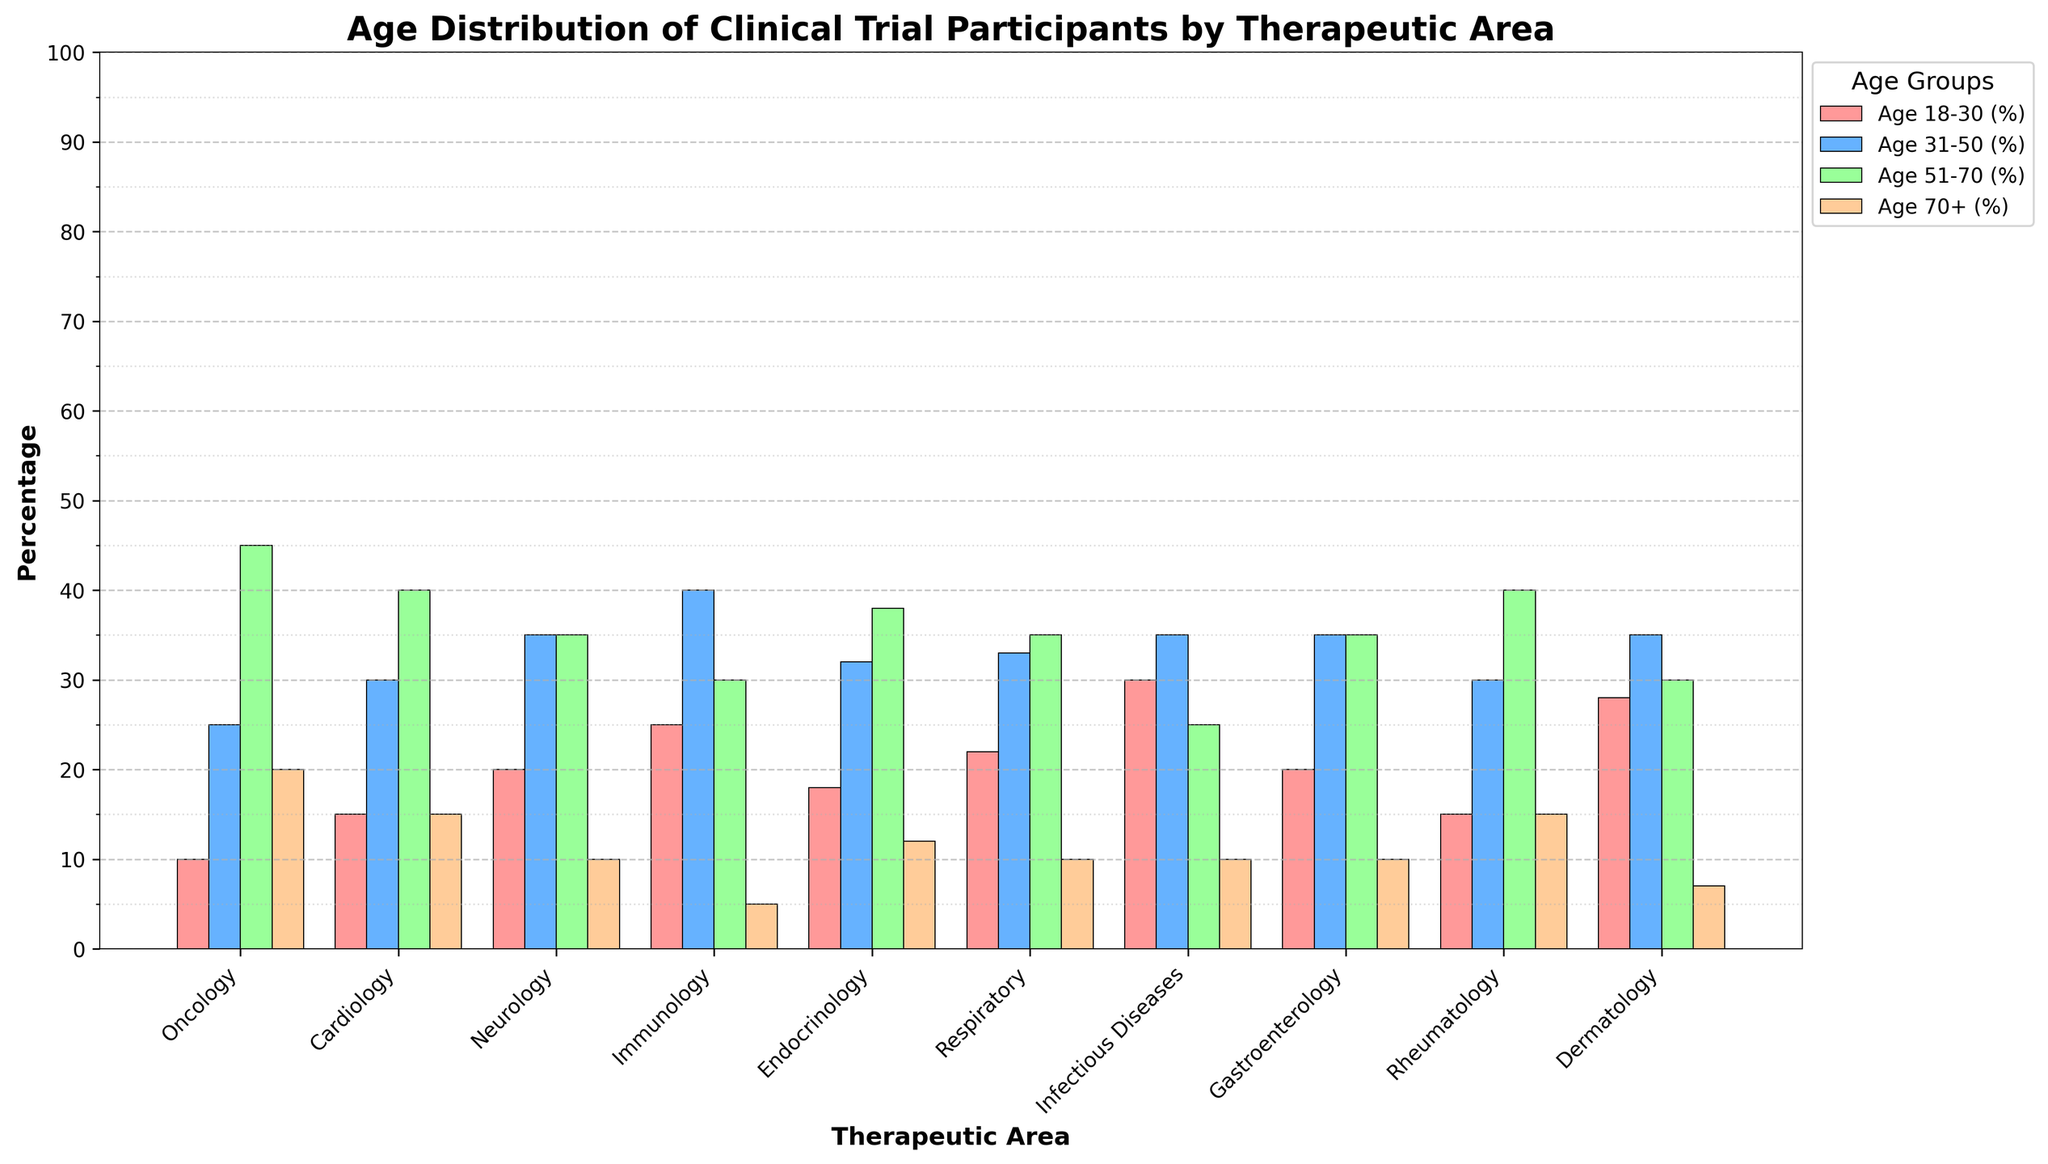Which therapeutic area has the highest percentage of participants in the age group 31-50? By looking at the bar representing the age group 31-50, we can see that Immunology has the highest bar for this age group.
Answer: Immunology How does the percentage of males in Cardiology compare to Rheumatology? The bar for males in Cardiology is higher than that in Rheumatology. Specifically, Cardiology has 55% males, while Rheumatology has 40%.
Answer: Cardiology has a higher percentage of males What is the average percentage of participants aged 18-30 in the areas of Oncology, Endocrinology, and Dermatology? Summing the percentages for the age group 18-30 in these areas: 10 (Oncology) + 18 (Endocrinology) + 28 (Dermatology) = 56. The average is then calculated by dividing by 3: 56/3 ≈ 18.67.
Answer: 18.67 Which therapeutic area has the smallest difference between the percentages of male and female participants? The smallest difference can be identified by comparing the bars for male and female participants in each therapeutic area. Rheumatology shows a difference of 20% (60% female - 40% male), which is the smallest among all areas.
Answer: Rheumatology What is the total percentage of participants aged 51-70 and above 70 in Neurology? By adding the percentages for age groups 51-70 and 70+: 35 (51-70) + 10 (70+) = 45.
Answer: 45 Which therapeutic areas have exactly the same percentage of Hispanic participants? By examining the bars for Hispanic participants, we observe that Oncology, Cardiology, Neurology, Immunology, Infectious Diseases, Dermatology all have 8% Hispanic participants.
Answer: Oncology, Cardiology, Neurology, Immunology, Infectious Diseases, Dermatology Is the height of the bar for participants aged 18-30 in Infectious Diseases greater than the height of the bar for participants aged 31-50 in Oncology? The height of the bar for age 18-30 in Infectious Diseases (30%) is greater than the bar for age 31-50 in Oncology (25%).
Answer: Yes Which therapeutic area has the highest number of age groups where the percentage of participants is above 30%? Immunology has three age groups with percentages above 30%: 18-30 (25%), 31-50 (40%), and 51-70 (30%).
Answer: Immunology What is the sum of the percentages of Black participants in Cardiology and Respiratory? Adding the percentages of Black participants in Cardiology (18%) and Respiratory (19%) gives us: 18 + 19 = 37.
Answer: 37 Which therapeutic area shows the most balanced gender distribution? The most balanced gender distribution would be where the bars for male and female participants are closest in height. Endocrinology has an equal percentage of males and females (50% each).
Answer: Endocrinology 